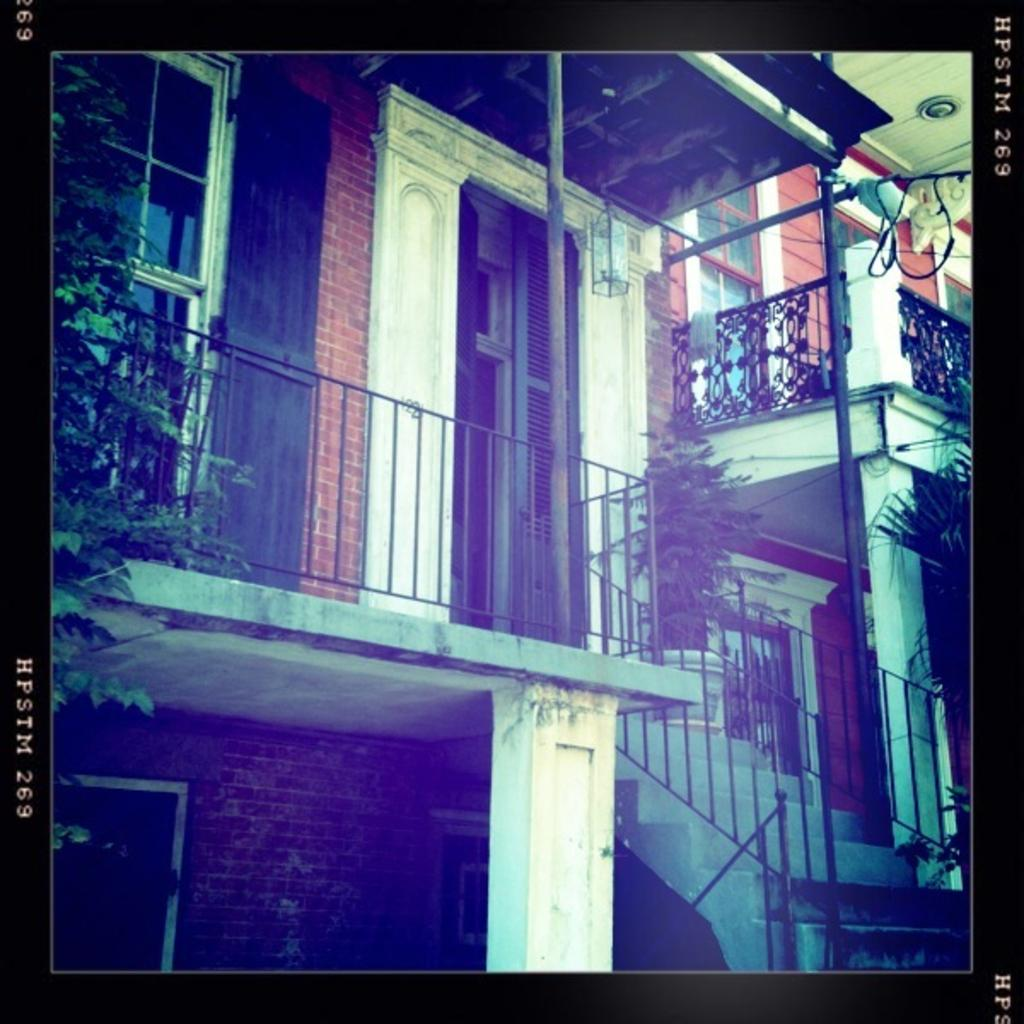What type of border surrounds the image? The image has borders, but the specific type is not mentioned in the facts. What type of structures can be seen in the image? There are houses, a railing, a staircase, windows, and a wall visible in the image. Can you describe the text in the image? There is text on both the right and left sides of the image. What decision did the committee make in the image? There is no mention of a committee or any decision-making process in the image. What type of offer is being made by the mother in the image? There is no mother or offer present in the image. 